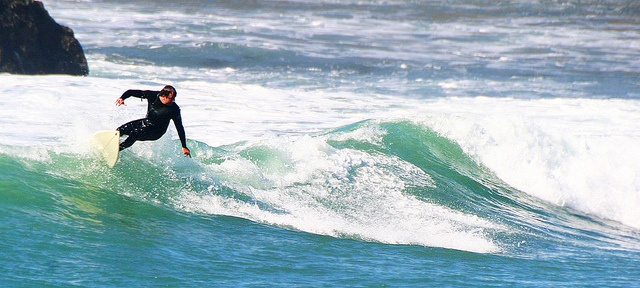Describe the objects in this image and their specific colors. I can see people in black, white, gray, and darkgray tones and surfboard in black, beige, olive, and darkgray tones in this image. 